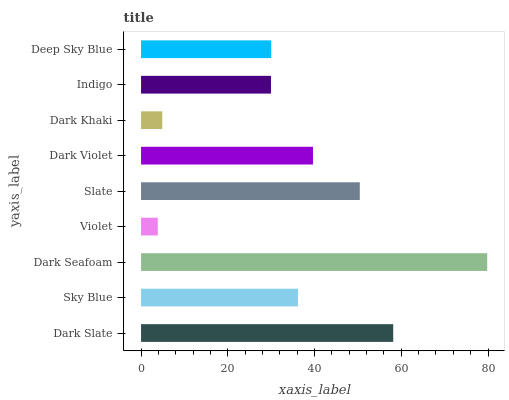Is Violet the minimum?
Answer yes or no. Yes. Is Dark Seafoam the maximum?
Answer yes or no. Yes. Is Sky Blue the minimum?
Answer yes or no. No. Is Sky Blue the maximum?
Answer yes or no. No. Is Dark Slate greater than Sky Blue?
Answer yes or no. Yes. Is Sky Blue less than Dark Slate?
Answer yes or no. Yes. Is Sky Blue greater than Dark Slate?
Answer yes or no. No. Is Dark Slate less than Sky Blue?
Answer yes or no. No. Is Sky Blue the high median?
Answer yes or no. Yes. Is Sky Blue the low median?
Answer yes or no. Yes. Is Slate the high median?
Answer yes or no. No. Is Dark Slate the low median?
Answer yes or no. No. 